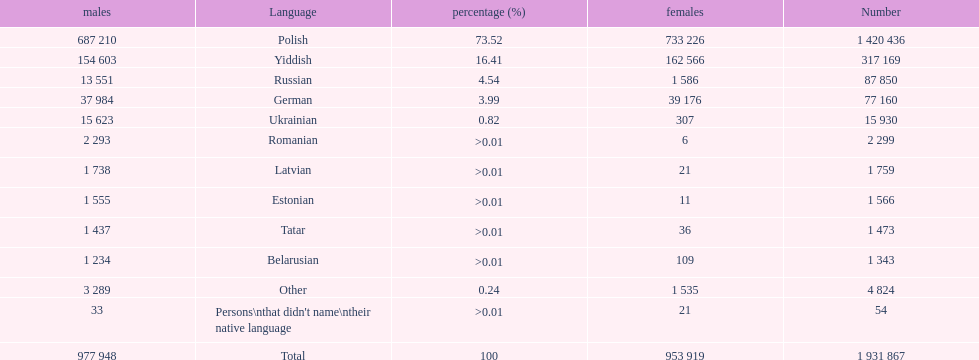What was the next most commonly spoken language in poland after russian? German. 